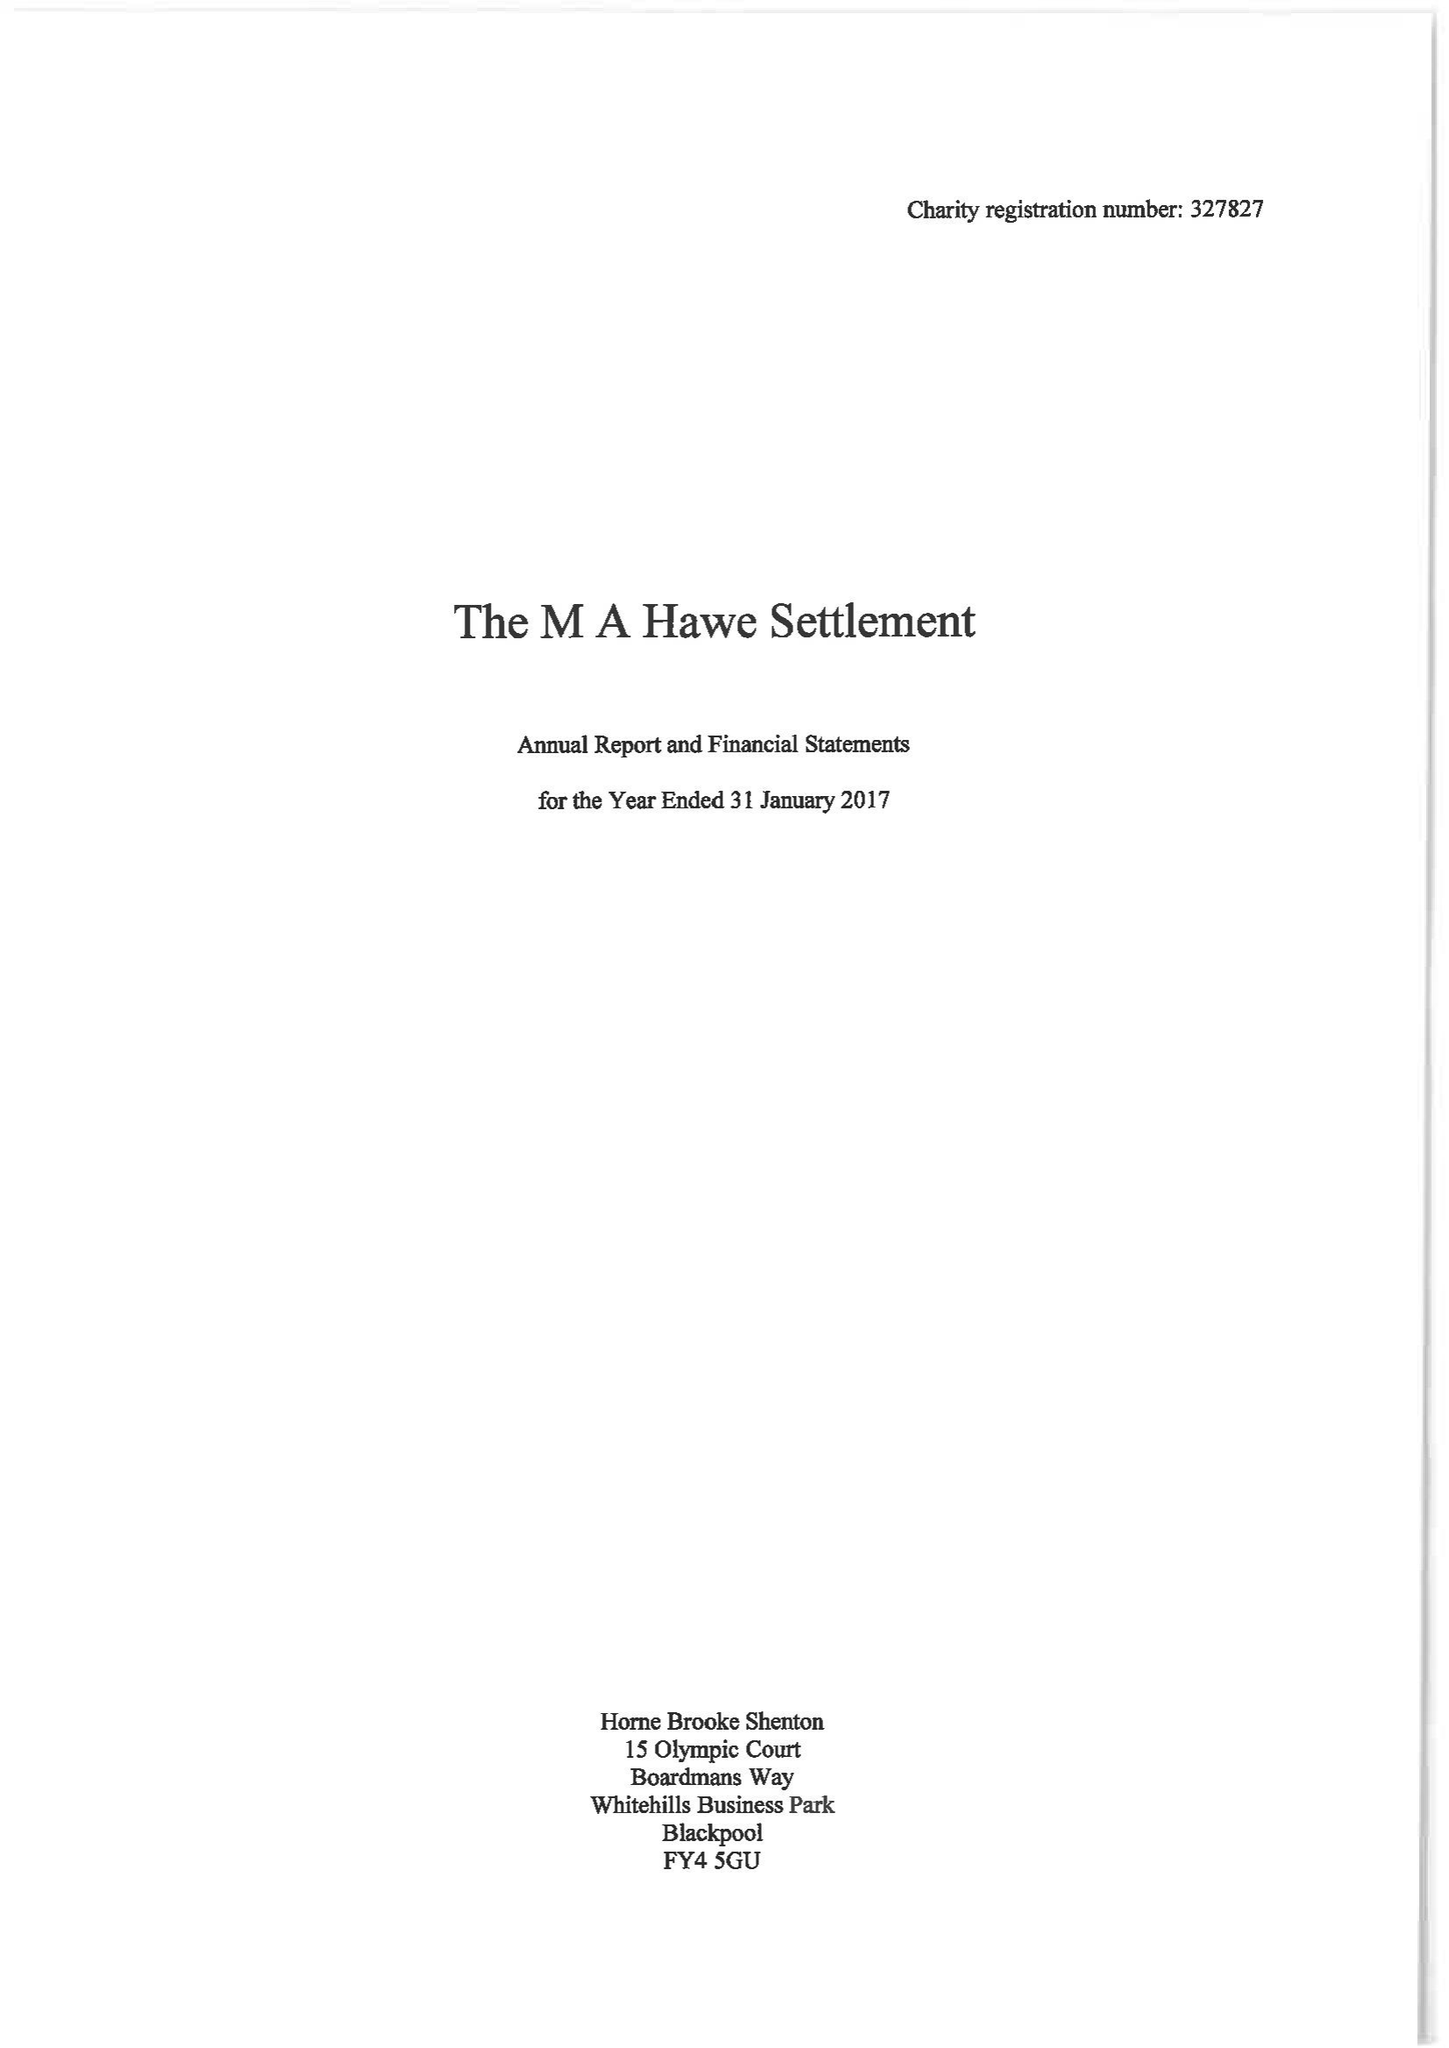What is the value for the charity_name?
Answer the question using a single word or phrase. The Ma Hawe Settlement 